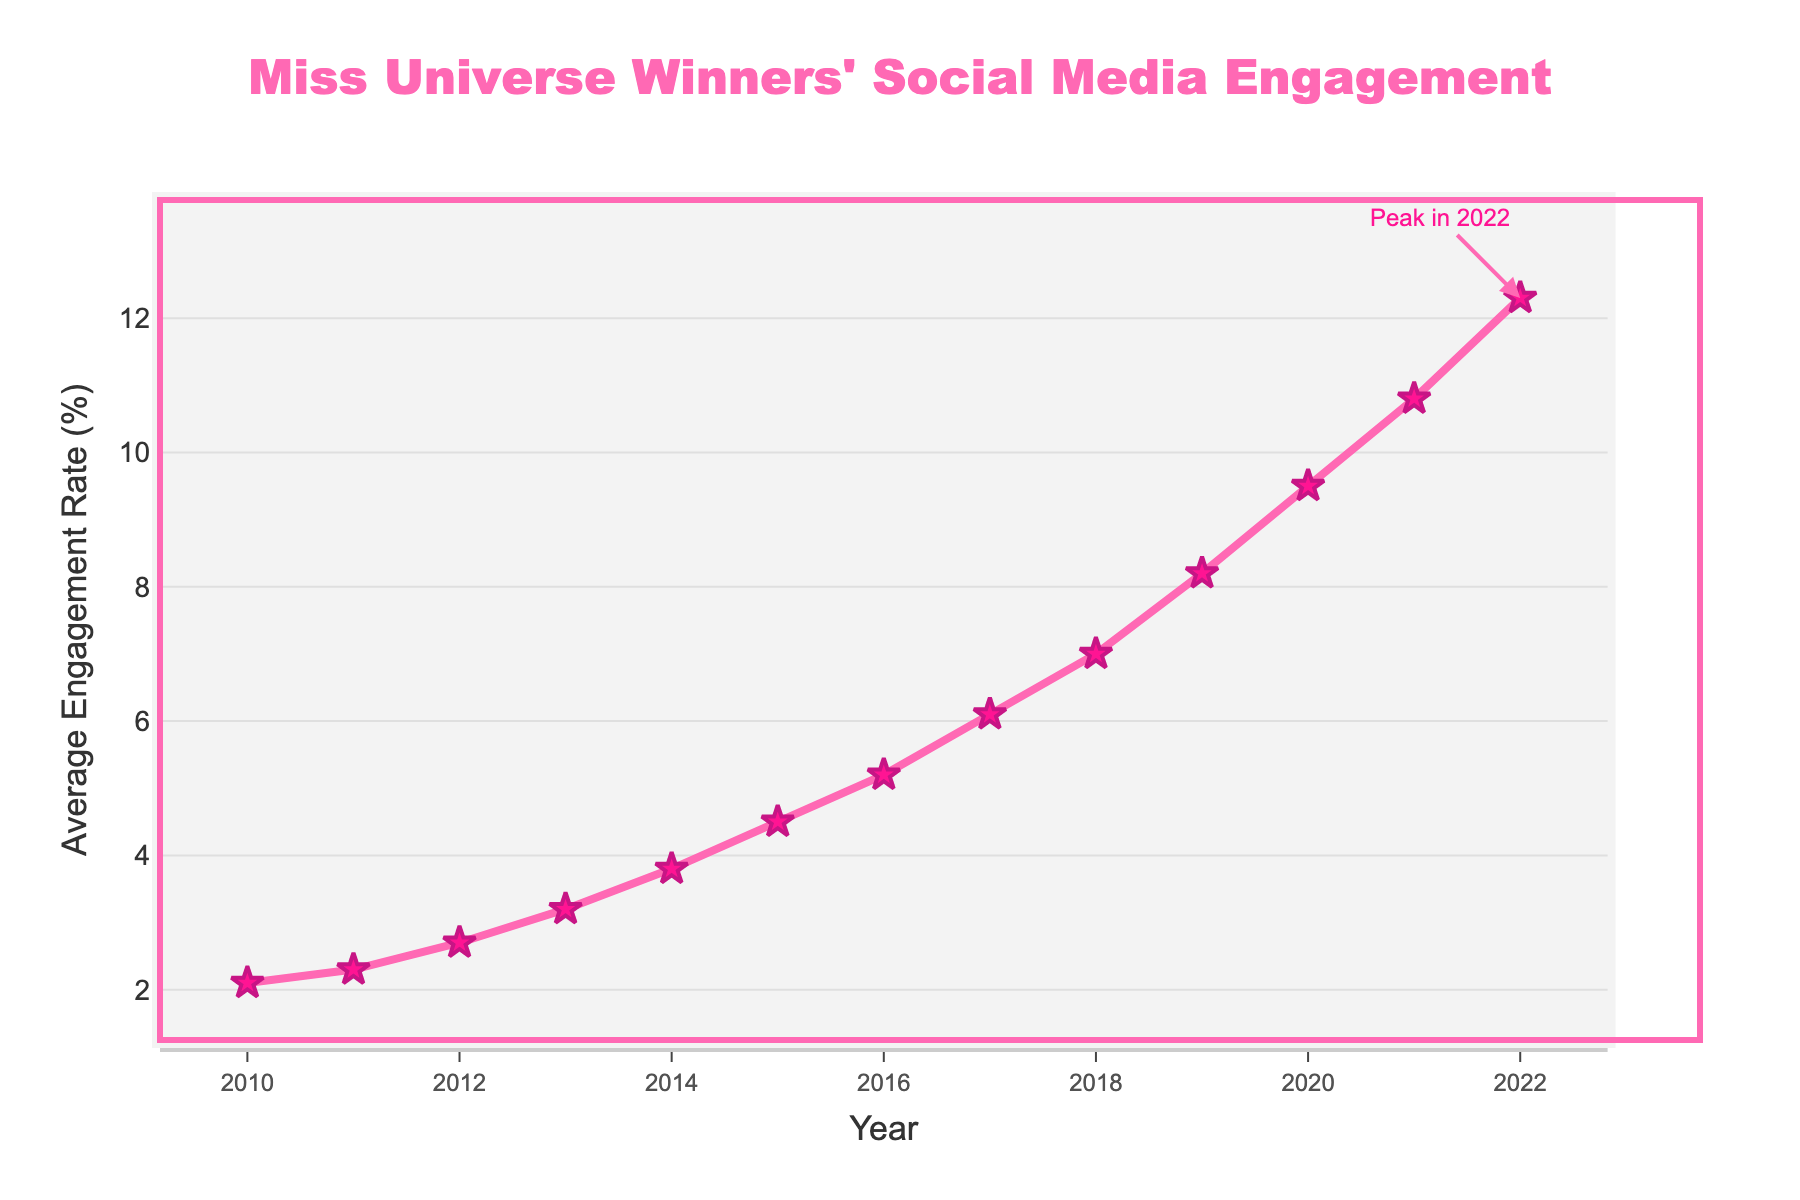Which year had the highest average engagement rate? The highest point on the line chart is at the year 2022.
Answer: 2022 What is the engagement rate difference between 2020 and 2022? In 2020, the engagement rate is 9.5%, and in 2022, it is 12.3%. The difference is 12.3% - 9.5% = 2.8%.
Answer: 2.8% How did the engagement rate change from 2015 to 2016? The engagement rate in 2015 was 4.5% and in 2016 it was 5.2%. Therefore, it increased by 5.2% - 4.5% = 0.7%.
Answer: It increased by 0.7% Which years show a consistent increase in engagement rate without any decrease? From the chart, we can see a consistent increase in the engagement rate from 2010 to 2022 without any decrease.
Answer: 2010-2022 In which year did the engagement rate first exceed 5%? The engagement rate first exceeds 5% in the year 2016 according to the chart.
Answer: 2016 What is the total increase in engagement rate from 2010 to 2022? The engagement rate in 2010 is 2.1%, and in 2022 it is 12.3%. The total increase is 12.3% - 2.1% = 10.2%.
Answer: 10.2% Which period saw the most significant increase in engagement rate? To find this, observe the slope between points: from 2021 to 2022 shows the most significant increase, rising from 10.8% to 12.3%, which is a 1.5% increase.
Answer: 2021-2022 What is the average engagement rate over the first five years (2010-2014)? The engagement rates from 2010 to 2014 are 2.1%, 2.3%, 2.7%, 3.2%, and 3.8%. Their sum is 14.1%. The average is 14.1% / 5 = 2.82%.
Answer: 2.82% Describe the visual trend in the engagement rates from 2010 to 2022. The line chart shows a consistent upward trend in social media engagement rates from 2010 to 2022. The line gets steeper, especially after 2018, indicating a more rapid increase in engagement rates.
Answer: Consistent upward trend How many years did it take for the engagement rate to double from its 2010 value? In 2010, the engagement rate was 2.1%. Doubling this would be 4.2%. By looking at the chart, the engagement rate exceeded 4.2% in 2015.
Answer: 5 years 